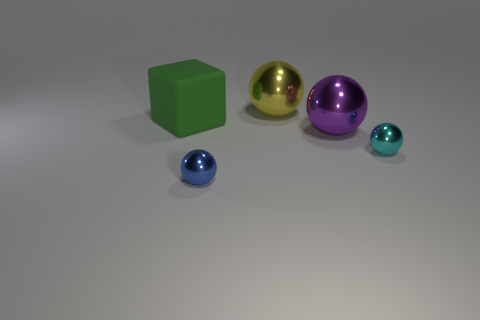What is the shape of the object that is left of the small object to the left of the big yellow metal thing?
Offer a very short reply. Cube. How many other things are there of the same shape as the small blue metal object?
Offer a very short reply. 3. There is a ball on the right side of the big sphere that is in front of the large matte object; what size is it?
Keep it short and to the point. Small. Is there a matte cube?
Provide a short and direct response. Yes. There is a thing that is left of the tiny blue object; how many big metallic things are in front of it?
Ensure brevity in your answer.  1. What shape is the small metal thing that is left of the large purple object?
Offer a very short reply. Sphere. What is the material of the tiny sphere that is to the right of the small sphere that is in front of the tiny metal sphere to the right of the yellow sphere?
Your answer should be very brief. Metal. What number of other objects are the same size as the green thing?
Provide a succinct answer. 2. What is the material of the tiny blue thing that is the same shape as the big purple shiny object?
Give a very brief answer. Metal. The rubber thing is what color?
Offer a terse response. Green. 